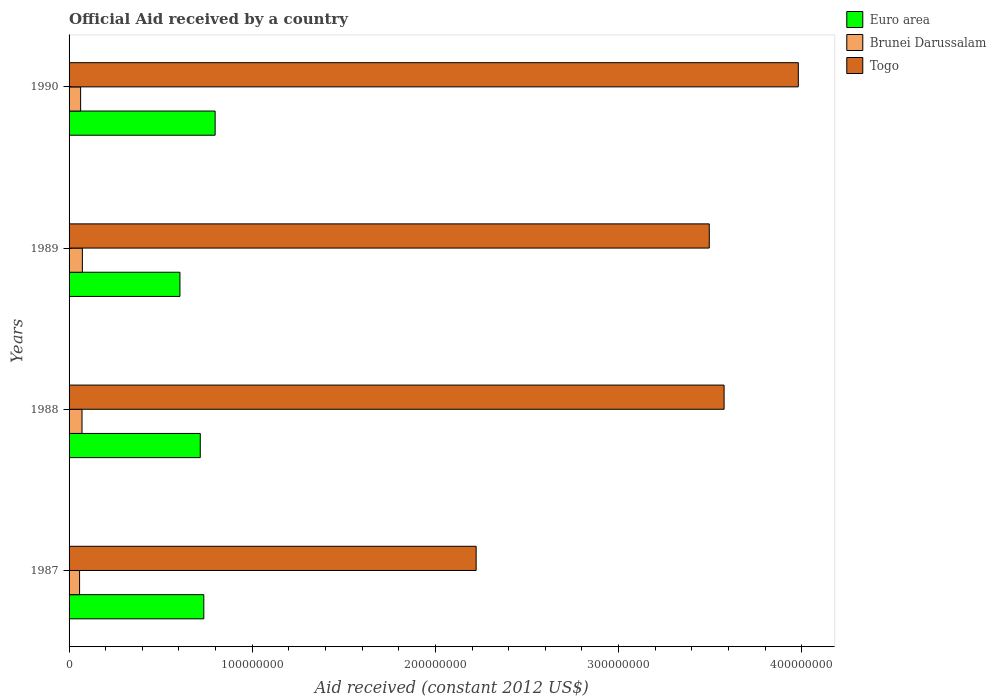How many different coloured bars are there?
Ensure brevity in your answer.  3. How many groups of bars are there?
Your answer should be very brief. 4. How many bars are there on the 1st tick from the top?
Keep it short and to the point. 3. What is the net official aid received in Togo in 1988?
Offer a terse response. 3.58e+08. Across all years, what is the maximum net official aid received in Togo?
Your answer should be compact. 3.98e+08. Across all years, what is the minimum net official aid received in Euro area?
Provide a succinct answer. 6.05e+07. In which year was the net official aid received in Brunei Darussalam maximum?
Keep it short and to the point. 1989. What is the total net official aid received in Brunei Darussalam in the graph?
Keep it short and to the point. 2.64e+07. What is the difference between the net official aid received in Brunei Darussalam in 1987 and that in 1988?
Provide a short and direct response. -1.33e+06. What is the difference between the net official aid received in Brunei Darussalam in 1988 and the net official aid received in Togo in 1989?
Offer a terse response. -3.42e+08. What is the average net official aid received in Togo per year?
Give a very brief answer. 3.32e+08. In the year 1988, what is the difference between the net official aid received in Togo and net official aid received in Euro area?
Offer a very short reply. 2.86e+08. What is the ratio of the net official aid received in Euro area in 1988 to that in 1990?
Offer a terse response. 0.9. Is the net official aid received in Togo in 1987 less than that in 1989?
Provide a short and direct response. Yes. Is the difference between the net official aid received in Togo in 1987 and 1990 greater than the difference between the net official aid received in Euro area in 1987 and 1990?
Your response must be concise. No. What is the difference between the highest and the second highest net official aid received in Euro area?
Provide a succinct answer. 6.18e+06. What is the difference between the highest and the lowest net official aid received in Togo?
Provide a succinct answer. 1.76e+08. In how many years, is the net official aid received in Togo greater than the average net official aid received in Togo taken over all years?
Your answer should be compact. 3. What does the 3rd bar from the top in 1988 represents?
Give a very brief answer. Euro area. What does the 3rd bar from the bottom in 1988 represents?
Offer a very short reply. Togo. How many bars are there?
Ensure brevity in your answer.  12. How many years are there in the graph?
Offer a very short reply. 4. Does the graph contain any zero values?
Your response must be concise. No. Does the graph contain grids?
Your response must be concise. No. Where does the legend appear in the graph?
Provide a short and direct response. Top right. What is the title of the graph?
Your response must be concise. Official Aid received by a country. Does "Swaziland" appear as one of the legend labels in the graph?
Provide a short and direct response. No. What is the label or title of the X-axis?
Provide a succinct answer. Aid received (constant 2012 US$). What is the Aid received (constant 2012 US$) in Euro area in 1987?
Give a very brief answer. 7.36e+07. What is the Aid received (constant 2012 US$) of Brunei Darussalam in 1987?
Keep it short and to the point. 5.74e+06. What is the Aid received (constant 2012 US$) of Togo in 1987?
Provide a succinct answer. 2.22e+08. What is the Aid received (constant 2012 US$) of Euro area in 1988?
Offer a very short reply. 7.16e+07. What is the Aid received (constant 2012 US$) of Brunei Darussalam in 1988?
Your answer should be very brief. 7.07e+06. What is the Aid received (constant 2012 US$) of Togo in 1988?
Your answer should be very brief. 3.58e+08. What is the Aid received (constant 2012 US$) in Euro area in 1989?
Provide a short and direct response. 6.05e+07. What is the Aid received (constant 2012 US$) in Brunei Darussalam in 1989?
Make the answer very short. 7.26e+06. What is the Aid received (constant 2012 US$) in Togo in 1989?
Keep it short and to the point. 3.50e+08. What is the Aid received (constant 2012 US$) of Euro area in 1990?
Your response must be concise. 7.98e+07. What is the Aid received (constant 2012 US$) of Brunei Darussalam in 1990?
Your response must be concise. 6.31e+06. What is the Aid received (constant 2012 US$) of Togo in 1990?
Your answer should be compact. 3.98e+08. Across all years, what is the maximum Aid received (constant 2012 US$) of Euro area?
Ensure brevity in your answer.  7.98e+07. Across all years, what is the maximum Aid received (constant 2012 US$) in Brunei Darussalam?
Offer a very short reply. 7.26e+06. Across all years, what is the maximum Aid received (constant 2012 US$) of Togo?
Your answer should be very brief. 3.98e+08. Across all years, what is the minimum Aid received (constant 2012 US$) of Euro area?
Your response must be concise. 6.05e+07. Across all years, what is the minimum Aid received (constant 2012 US$) in Brunei Darussalam?
Give a very brief answer. 5.74e+06. Across all years, what is the minimum Aid received (constant 2012 US$) of Togo?
Offer a very short reply. 2.22e+08. What is the total Aid received (constant 2012 US$) in Euro area in the graph?
Keep it short and to the point. 2.85e+08. What is the total Aid received (constant 2012 US$) of Brunei Darussalam in the graph?
Ensure brevity in your answer.  2.64e+07. What is the total Aid received (constant 2012 US$) in Togo in the graph?
Your answer should be very brief. 1.33e+09. What is the difference between the Aid received (constant 2012 US$) of Euro area in 1987 and that in 1988?
Your answer should be very brief. 1.94e+06. What is the difference between the Aid received (constant 2012 US$) in Brunei Darussalam in 1987 and that in 1988?
Offer a terse response. -1.33e+06. What is the difference between the Aid received (constant 2012 US$) of Togo in 1987 and that in 1988?
Offer a terse response. -1.35e+08. What is the difference between the Aid received (constant 2012 US$) in Euro area in 1987 and that in 1989?
Provide a short and direct response. 1.30e+07. What is the difference between the Aid received (constant 2012 US$) of Brunei Darussalam in 1987 and that in 1989?
Make the answer very short. -1.52e+06. What is the difference between the Aid received (constant 2012 US$) of Togo in 1987 and that in 1989?
Offer a very short reply. -1.27e+08. What is the difference between the Aid received (constant 2012 US$) of Euro area in 1987 and that in 1990?
Keep it short and to the point. -6.18e+06. What is the difference between the Aid received (constant 2012 US$) in Brunei Darussalam in 1987 and that in 1990?
Keep it short and to the point. -5.70e+05. What is the difference between the Aid received (constant 2012 US$) of Togo in 1987 and that in 1990?
Ensure brevity in your answer.  -1.76e+08. What is the difference between the Aid received (constant 2012 US$) of Euro area in 1988 and that in 1989?
Keep it short and to the point. 1.11e+07. What is the difference between the Aid received (constant 2012 US$) of Togo in 1988 and that in 1989?
Offer a terse response. 8.09e+06. What is the difference between the Aid received (constant 2012 US$) in Euro area in 1988 and that in 1990?
Provide a short and direct response. -8.12e+06. What is the difference between the Aid received (constant 2012 US$) in Brunei Darussalam in 1988 and that in 1990?
Your answer should be compact. 7.60e+05. What is the difference between the Aid received (constant 2012 US$) in Togo in 1988 and that in 1990?
Your response must be concise. -4.05e+07. What is the difference between the Aid received (constant 2012 US$) of Euro area in 1989 and that in 1990?
Offer a very short reply. -1.92e+07. What is the difference between the Aid received (constant 2012 US$) of Brunei Darussalam in 1989 and that in 1990?
Make the answer very short. 9.50e+05. What is the difference between the Aid received (constant 2012 US$) of Togo in 1989 and that in 1990?
Offer a very short reply. -4.86e+07. What is the difference between the Aid received (constant 2012 US$) in Euro area in 1987 and the Aid received (constant 2012 US$) in Brunei Darussalam in 1988?
Your answer should be compact. 6.65e+07. What is the difference between the Aid received (constant 2012 US$) of Euro area in 1987 and the Aid received (constant 2012 US$) of Togo in 1988?
Give a very brief answer. -2.84e+08. What is the difference between the Aid received (constant 2012 US$) in Brunei Darussalam in 1987 and the Aid received (constant 2012 US$) in Togo in 1988?
Give a very brief answer. -3.52e+08. What is the difference between the Aid received (constant 2012 US$) in Euro area in 1987 and the Aid received (constant 2012 US$) in Brunei Darussalam in 1989?
Offer a terse response. 6.63e+07. What is the difference between the Aid received (constant 2012 US$) of Euro area in 1987 and the Aid received (constant 2012 US$) of Togo in 1989?
Your answer should be very brief. -2.76e+08. What is the difference between the Aid received (constant 2012 US$) in Brunei Darussalam in 1987 and the Aid received (constant 2012 US$) in Togo in 1989?
Make the answer very short. -3.44e+08. What is the difference between the Aid received (constant 2012 US$) in Euro area in 1987 and the Aid received (constant 2012 US$) in Brunei Darussalam in 1990?
Provide a succinct answer. 6.73e+07. What is the difference between the Aid received (constant 2012 US$) in Euro area in 1987 and the Aid received (constant 2012 US$) in Togo in 1990?
Your answer should be very brief. -3.25e+08. What is the difference between the Aid received (constant 2012 US$) of Brunei Darussalam in 1987 and the Aid received (constant 2012 US$) of Togo in 1990?
Offer a very short reply. -3.92e+08. What is the difference between the Aid received (constant 2012 US$) of Euro area in 1988 and the Aid received (constant 2012 US$) of Brunei Darussalam in 1989?
Your answer should be very brief. 6.44e+07. What is the difference between the Aid received (constant 2012 US$) in Euro area in 1988 and the Aid received (constant 2012 US$) in Togo in 1989?
Your response must be concise. -2.78e+08. What is the difference between the Aid received (constant 2012 US$) of Brunei Darussalam in 1988 and the Aid received (constant 2012 US$) of Togo in 1989?
Your answer should be very brief. -3.42e+08. What is the difference between the Aid received (constant 2012 US$) in Euro area in 1988 and the Aid received (constant 2012 US$) in Brunei Darussalam in 1990?
Offer a very short reply. 6.53e+07. What is the difference between the Aid received (constant 2012 US$) of Euro area in 1988 and the Aid received (constant 2012 US$) of Togo in 1990?
Your answer should be very brief. -3.27e+08. What is the difference between the Aid received (constant 2012 US$) in Brunei Darussalam in 1988 and the Aid received (constant 2012 US$) in Togo in 1990?
Provide a succinct answer. -3.91e+08. What is the difference between the Aid received (constant 2012 US$) of Euro area in 1989 and the Aid received (constant 2012 US$) of Brunei Darussalam in 1990?
Make the answer very short. 5.42e+07. What is the difference between the Aid received (constant 2012 US$) of Euro area in 1989 and the Aid received (constant 2012 US$) of Togo in 1990?
Give a very brief answer. -3.38e+08. What is the difference between the Aid received (constant 2012 US$) in Brunei Darussalam in 1989 and the Aid received (constant 2012 US$) in Togo in 1990?
Provide a short and direct response. -3.91e+08. What is the average Aid received (constant 2012 US$) of Euro area per year?
Make the answer very short. 7.14e+07. What is the average Aid received (constant 2012 US$) in Brunei Darussalam per year?
Your response must be concise. 6.60e+06. What is the average Aid received (constant 2012 US$) of Togo per year?
Your answer should be compact. 3.32e+08. In the year 1987, what is the difference between the Aid received (constant 2012 US$) in Euro area and Aid received (constant 2012 US$) in Brunei Darussalam?
Your answer should be very brief. 6.78e+07. In the year 1987, what is the difference between the Aid received (constant 2012 US$) of Euro area and Aid received (constant 2012 US$) of Togo?
Give a very brief answer. -1.49e+08. In the year 1987, what is the difference between the Aid received (constant 2012 US$) of Brunei Darussalam and Aid received (constant 2012 US$) of Togo?
Offer a very short reply. -2.17e+08. In the year 1988, what is the difference between the Aid received (constant 2012 US$) of Euro area and Aid received (constant 2012 US$) of Brunei Darussalam?
Ensure brevity in your answer.  6.46e+07. In the year 1988, what is the difference between the Aid received (constant 2012 US$) of Euro area and Aid received (constant 2012 US$) of Togo?
Your answer should be compact. -2.86e+08. In the year 1988, what is the difference between the Aid received (constant 2012 US$) in Brunei Darussalam and Aid received (constant 2012 US$) in Togo?
Make the answer very short. -3.51e+08. In the year 1989, what is the difference between the Aid received (constant 2012 US$) in Euro area and Aid received (constant 2012 US$) in Brunei Darussalam?
Keep it short and to the point. 5.33e+07. In the year 1989, what is the difference between the Aid received (constant 2012 US$) in Euro area and Aid received (constant 2012 US$) in Togo?
Offer a terse response. -2.89e+08. In the year 1989, what is the difference between the Aid received (constant 2012 US$) in Brunei Darussalam and Aid received (constant 2012 US$) in Togo?
Offer a terse response. -3.42e+08. In the year 1990, what is the difference between the Aid received (constant 2012 US$) in Euro area and Aid received (constant 2012 US$) in Brunei Darussalam?
Your answer should be compact. 7.34e+07. In the year 1990, what is the difference between the Aid received (constant 2012 US$) of Euro area and Aid received (constant 2012 US$) of Togo?
Your answer should be compact. -3.18e+08. In the year 1990, what is the difference between the Aid received (constant 2012 US$) of Brunei Darussalam and Aid received (constant 2012 US$) of Togo?
Provide a short and direct response. -3.92e+08. What is the ratio of the Aid received (constant 2012 US$) of Euro area in 1987 to that in 1988?
Keep it short and to the point. 1.03. What is the ratio of the Aid received (constant 2012 US$) in Brunei Darussalam in 1987 to that in 1988?
Give a very brief answer. 0.81. What is the ratio of the Aid received (constant 2012 US$) of Togo in 1987 to that in 1988?
Offer a terse response. 0.62. What is the ratio of the Aid received (constant 2012 US$) in Euro area in 1987 to that in 1989?
Offer a very short reply. 1.22. What is the ratio of the Aid received (constant 2012 US$) of Brunei Darussalam in 1987 to that in 1989?
Make the answer very short. 0.79. What is the ratio of the Aid received (constant 2012 US$) of Togo in 1987 to that in 1989?
Ensure brevity in your answer.  0.64. What is the ratio of the Aid received (constant 2012 US$) in Euro area in 1987 to that in 1990?
Provide a short and direct response. 0.92. What is the ratio of the Aid received (constant 2012 US$) of Brunei Darussalam in 1987 to that in 1990?
Make the answer very short. 0.91. What is the ratio of the Aid received (constant 2012 US$) of Togo in 1987 to that in 1990?
Keep it short and to the point. 0.56. What is the ratio of the Aid received (constant 2012 US$) in Euro area in 1988 to that in 1989?
Your answer should be compact. 1.18. What is the ratio of the Aid received (constant 2012 US$) of Brunei Darussalam in 1988 to that in 1989?
Your answer should be compact. 0.97. What is the ratio of the Aid received (constant 2012 US$) of Togo in 1988 to that in 1989?
Offer a very short reply. 1.02. What is the ratio of the Aid received (constant 2012 US$) in Euro area in 1988 to that in 1990?
Provide a short and direct response. 0.9. What is the ratio of the Aid received (constant 2012 US$) of Brunei Darussalam in 1988 to that in 1990?
Provide a short and direct response. 1.12. What is the ratio of the Aid received (constant 2012 US$) of Togo in 1988 to that in 1990?
Offer a very short reply. 0.9. What is the ratio of the Aid received (constant 2012 US$) of Euro area in 1989 to that in 1990?
Ensure brevity in your answer.  0.76. What is the ratio of the Aid received (constant 2012 US$) of Brunei Darussalam in 1989 to that in 1990?
Offer a very short reply. 1.15. What is the ratio of the Aid received (constant 2012 US$) of Togo in 1989 to that in 1990?
Your response must be concise. 0.88. What is the difference between the highest and the second highest Aid received (constant 2012 US$) of Euro area?
Ensure brevity in your answer.  6.18e+06. What is the difference between the highest and the second highest Aid received (constant 2012 US$) of Brunei Darussalam?
Offer a terse response. 1.90e+05. What is the difference between the highest and the second highest Aid received (constant 2012 US$) of Togo?
Your response must be concise. 4.05e+07. What is the difference between the highest and the lowest Aid received (constant 2012 US$) of Euro area?
Your response must be concise. 1.92e+07. What is the difference between the highest and the lowest Aid received (constant 2012 US$) of Brunei Darussalam?
Make the answer very short. 1.52e+06. What is the difference between the highest and the lowest Aid received (constant 2012 US$) in Togo?
Give a very brief answer. 1.76e+08. 